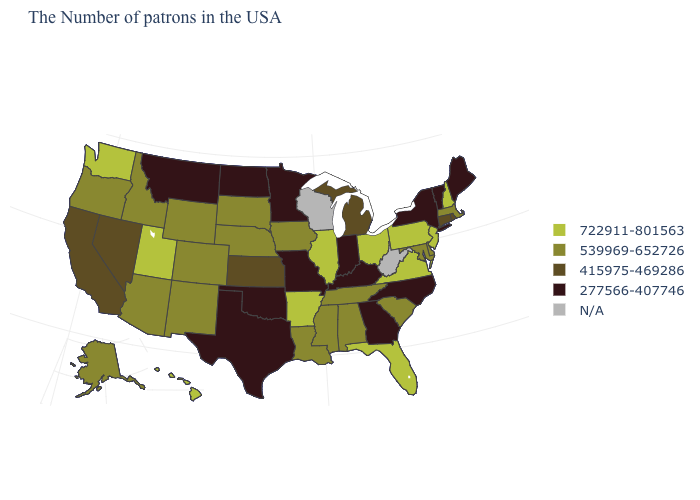Name the states that have a value in the range N/A?
Short answer required. West Virginia, Wisconsin. What is the value of New Jersey?
Concise answer only. 722911-801563. What is the value of Vermont?
Answer briefly. 277566-407746. Does New Jersey have the lowest value in the Northeast?
Write a very short answer. No. Among the states that border Missouri , which have the lowest value?
Quick response, please. Kentucky, Oklahoma. What is the value of Georgia?
Quick response, please. 277566-407746. Name the states that have a value in the range 277566-407746?
Quick response, please. Maine, Vermont, New York, North Carolina, Georgia, Kentucky, Indiana, Missouri, Minnesota, Oklahoma, Texas, North Dakota, Montana. Does Alaska have the highest value in the USA?
Give a very brief answer. No. Name the states that have a value in the range 415975-469286?
Concise answer only. Rhode Island, Connecticut, Michigan, Kansas, Nevada, California. Name the states that have a value in the range 277566-407746?
Answer briefly. Maine, Vermont, New York, North Carolina, Georgia, Kentucky, Indiana, Missouri, Minnesota, Oklahoma, Texas, North Dakota, Montana. Name the states that have a value in the range 415975-469286?
Give a very brief answer. Rhode Island, Connecticut, Michigan, Kansas, Nevada, California. Name the states that have a value in the range 722911-801563?
Be succinct. New Hampshire, New Jersey, Pennsylvania, Virginia, Ohio, Florida, Illinois, Arkansas, Utah, Washington, Hawaii. What is the value of South Dakota?
Short answer required. 539969-652726. Among the states that border Minnesota , which have the lowest value?
Quick response, please. North Dakota. Name the states that have a value in the range 722911-801563?
Concise answer only. New Hampshire, New Jersey, Pennsylvania, Virginia, Ohio, Florida, Illinois, Arkansas, Utah, Washington, Hawaii. 